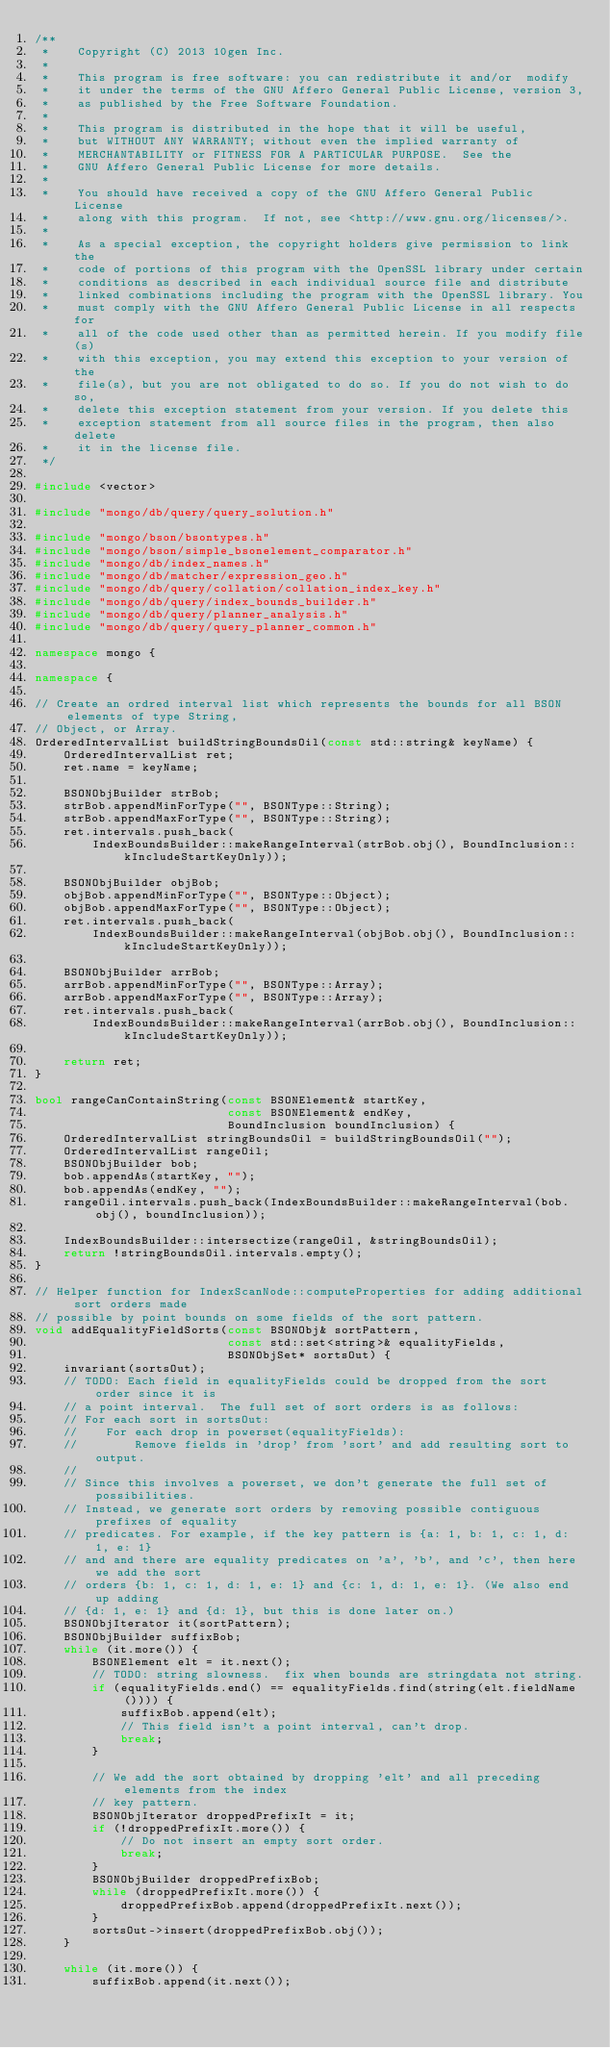<code> <loc_0><loc_0><loc_500><loc_500><_C++_>/**
 *    Copyright (C) 2013 10gen Inc.
 *
 *    This program is free software: you can redistribute it and/or  modify
 *    it under the terms of the GNU Affero General Public License, version 3,
 *    as published by the Free Software Foundation.
 *
 *    This program is distributed in the hope that it will be useful,
 *    but WITHOUT ANY WARRANTY; without even the implied warranty of
 *    MERCHANTABILITY or FITNESS FOR A PARTICULAR PURPOSE.  See the
 *    GNU Affero General Public License for more details.
 *
 *    You should have received a copy of the GNU Affero General Public License
 *    along with this program.  If not, see <http://www.gnu.org/licenses/>.
 *
 *    As a special exception, the copyright holders give permission to link the
 *    code of portions of this program with the OpenSSL library under certain
 *    conditions as described in each individual source file and distribute
 *    linked combinations including the program with the OpenSSL library. You
 *    must comply with the GNU Affero General Public License in all respects for
 *    all of the code used other than as permitted herein. If you modify file(s)
 *    with this exception, you may extend this exception to your version of the
 *    file(s), but you are not obligated to do so. If you do not wish to do so,
 *    delete this exception statement from your version. If you delete this
 *    exception statement from all source files in the program, then also delete
 *    it in the license file.
 */

#include <vector>

#include "mongo/db/query/query_solution.h"

#include "mongo/bson/bsontypes.h"
#include "mongo/bson/simple_bsonelement_comparator.h"
#include "mongo/db/index_names.h"
#include "mongo/db/matcher/expression_geo.h"
#include "mongo/db/query/collation/collation_index_key.h"
#include "mongo/db/query/index_bounds_builder.h"
#include "mongo/db/query/planner_analysis.h"
#include "mongo/db/query/query_planner_common.h"

namespace mongo {

namespace {

// Create an ordred interval list which represents the bounds for all BSON elements of type String,
// Object, or Array.
OrderedIntervalList buildStringBoundsOil(const std::string& keyName) {
    OrderedIntervalList ret;
    ret.name = keyName;

    BSONObjBuilder strBob;
    strBob.appendMinForType("", BSONType::String);
    strBob.appendMaxForType("", BSONType::String);
    ret.intervals.push_back(
        IndexBoundsBuilder::makeRangeInterval(strBob.obj(), BoundInclusion::kIncludeStartKeyOnly));

    BSONObjBuilder objBob;
    objBob.appendMinForType("", BSONType::Object);
    objBob.appendMaxForType("", BSONType::Object);
    ret.intervals.push_back(
        IndexBoundsBuilder::makeRangeInterval(objBob.obj(), BoundInclusion::kIncludeStartKeyOnly));

    BSONObjBuilder arrBob;
    arrBob.appendMinForType("", BSONType::Array);
    arrBob.appendMaxForType("", BSONType::Array);
    ret.intervals.push_back(
        IndexBoundsBuilder::makeRangeInterval(arrBob.obj(), BoundInclusion::kIncludeStartKeyOnly));

    return ret;
}

bool rangeCanContainString(const BSONElement& startKey,
                           const BSONElement& endKey,
                           BoundInclusion boundInclusion) {
    OrderedIntervalList stringBoundsOil = buildStringBoundsOil("");
    OrderedIntervalList rangeOil;
    BSONObjBuilder bob;
    bob.appendAs(startKey, "");
    bob.appendAs(endKey, "");
    rangeOil.intervals.push_back(IndexBoundsBuilder::makeRangeInterval(bob.obj(), boundInclusion));

    IndexBoundsBuilder::intersectize(rangeOil, &stringBoundsOil);
    return !stringBoundsOil.intervals.empty();
}

// Helper function for IndexScanNode::computeProperties for adding additional sort orders made
// possible by point bounds on some fields of the sort pattern.
void addEqualityFieldSorts(const BSONObj& sortPattern,
                           const std::set<string>& equalityFields,
                           BSONObjSet* sortsOut) {
    invariant(sortsOut);
    // TODO: Each field in equalityFields could be dropped from the sort order since it is
    // a point interval.  The full set of sort orders is as follows:
    // For each sort in sortsOut:
    //    For each drop in powerset(equalityFields):
    //        Remove fields in 'drop' from 'sort' and add resulting sort to output.
    //
    // Since this involves a powerset, we don't generate the full set of possibilities.
    // Instead, we generate sort orders by removing possible contiguous prefixes of equality
    // predicates. For example, if the key pattern is {a: 1, b: 1, c: 1, d: 1, e: 1}
    // and and there are equality predicates on 'a', 'b', and 'c', then here we add the sort
    // orders {b: 1, c: 1, d: 1, e: 1} and {c: 1, d: 1, e: 1}. (We also end up adding
    // {d: 1, e: 1} and {d: 1}, but this is done later on.)
    BSONObjIterator it(sortPattern);
    BSONObjBuilder suffixBob;
    while (it.more()) {
        BSONElement elt = it.next();
        // TODO: string slowness.  fix when bounds are stringdata not string.
        if (equalityFields.end() == equalityFields.find(string(elt.fieldName()))) {
            suffixBob.append(elt);
            // This field isn't a point interval, can't drop.
            break;
        }

        // We add the sort obtained by dropping 'elt' and all preceding elements from the index
        // key pattern.
        BSONObjIterator droppedPrefixIt = it;
        if (!droppedPrefixIt.more()) {
            // Do not insert an empty sort order.
            break;
        }
        BSONObjBuilder droppedPrefixBob;
        while (droppedPrefixIt.more()) {
            droppedPrefixBob.append(droppedPrefixIt.next());
        }
        sortsOut->insert(droppedPrefixBob.obj());
    }

    while (it.more()) {
        suffixBob.append(it.next());</code> 